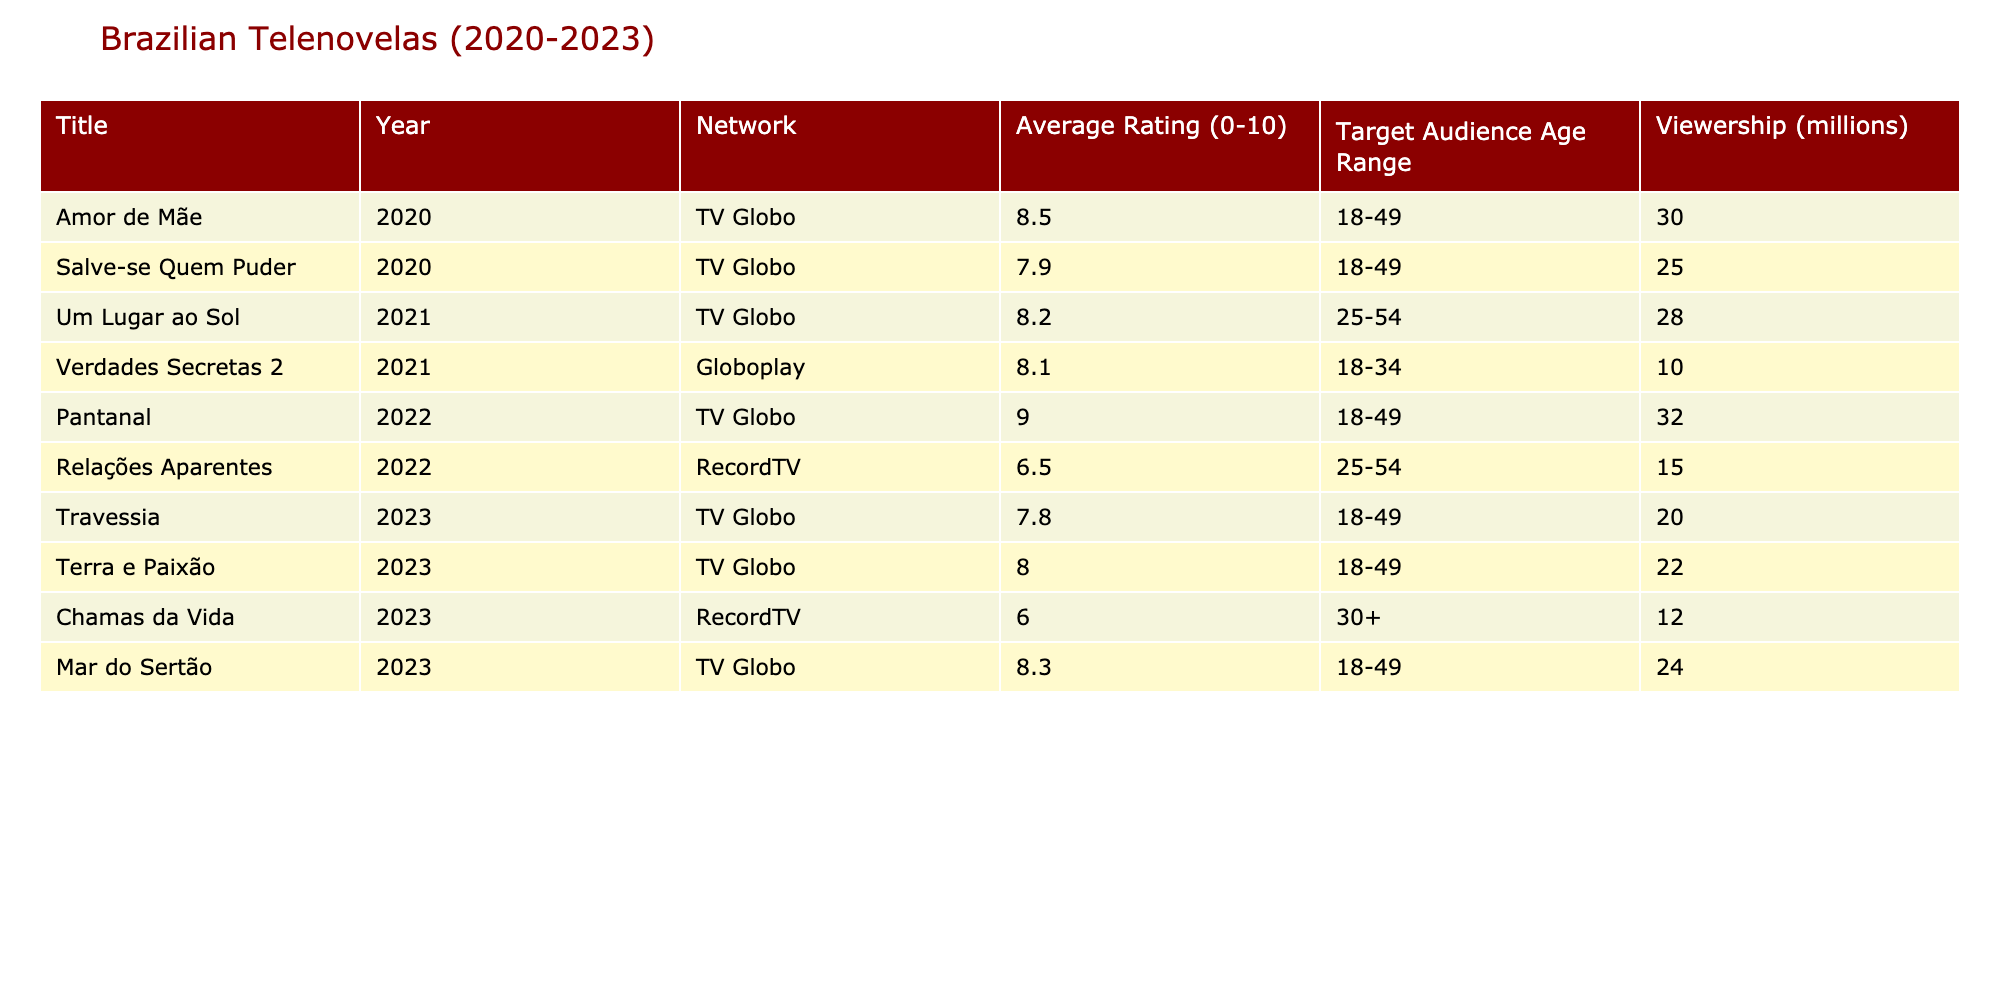What is the title of the telenovela with the highest average rating? Looking at the "Average Rating" column, "Pantanal" has the highest value of 9.0, which is greater than all other telenovelas listed.
Answer: Pantanal How many millions of viewers did "Amor de Mãe" have? The "Viewership" column shows that "Amor de Mãe" had 30 million viewers.
Answer: 30 million Which network aired "Relações Aparentes"? By checking the "Network" column associated with "Relações Aparentes", it shows that it was aired on "RecordTV".
Answer: RecordTV What is the average rating of the telenovelas aired in 2022? To calculate the average rating for 2022, we take the ratings of "Pantanal" (9.0) and "Relações Aparentes" (6.5), sum them to get 15.5, then divide by 2 for an average of 7.75.
Answer: 7.75 Did "Vale a Pena Ver de Novo" air during this time period? Checking the table, "Vale a Pena Ver de Novo" is not listed among the telenovelas, indicating it did not air during this time.
Answer: No Which telenovela had the highest viewership among those targeting audiences aged 18-49 in 2023? In 2023, "Mar do Sertão" (24 million) has the highest viewership in the age range of 18-49, compared to others from the same demographic.
Answer: Mar do Sertão What is the difference in viewership between "Verdades Secretas 2" and "Chamas da Vida"? The viewership for "Verdades Secretas 2" is 10 million and for "Chamas da Vida" is 12 million. The difference is 12 - 10 = 2 million.
Answer: 2 million Which telenovela had a rating below 7.0? By looking at the "Average Rating" column, "Chamas da Vida" (6.0) is the only telenovela listed with a rating below 7.0.
Answer: Chamas da Vida How many telenovelas were aired by TV Globo in 2020? The table lists "Amor de Mãe" and "Salve-se Quem Puder" as the only telenovelas aired by TV Globo in 2020, giving a total of 2.
Answer: 2 